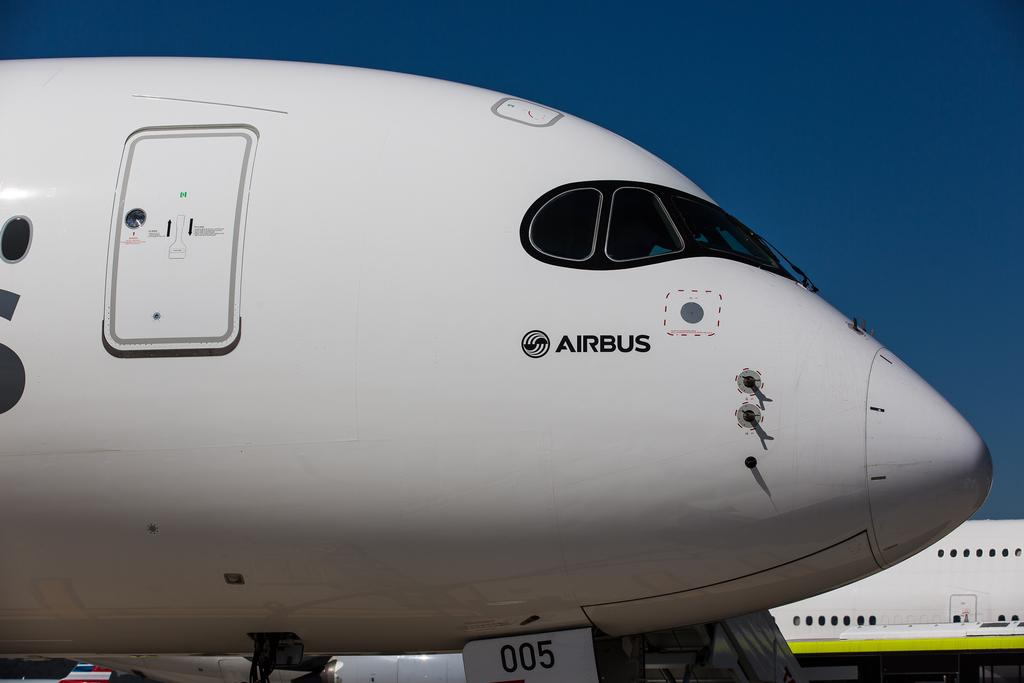<image>
Share a concise interpretation of the image provided. A large white Airbus airplane on the ground. 